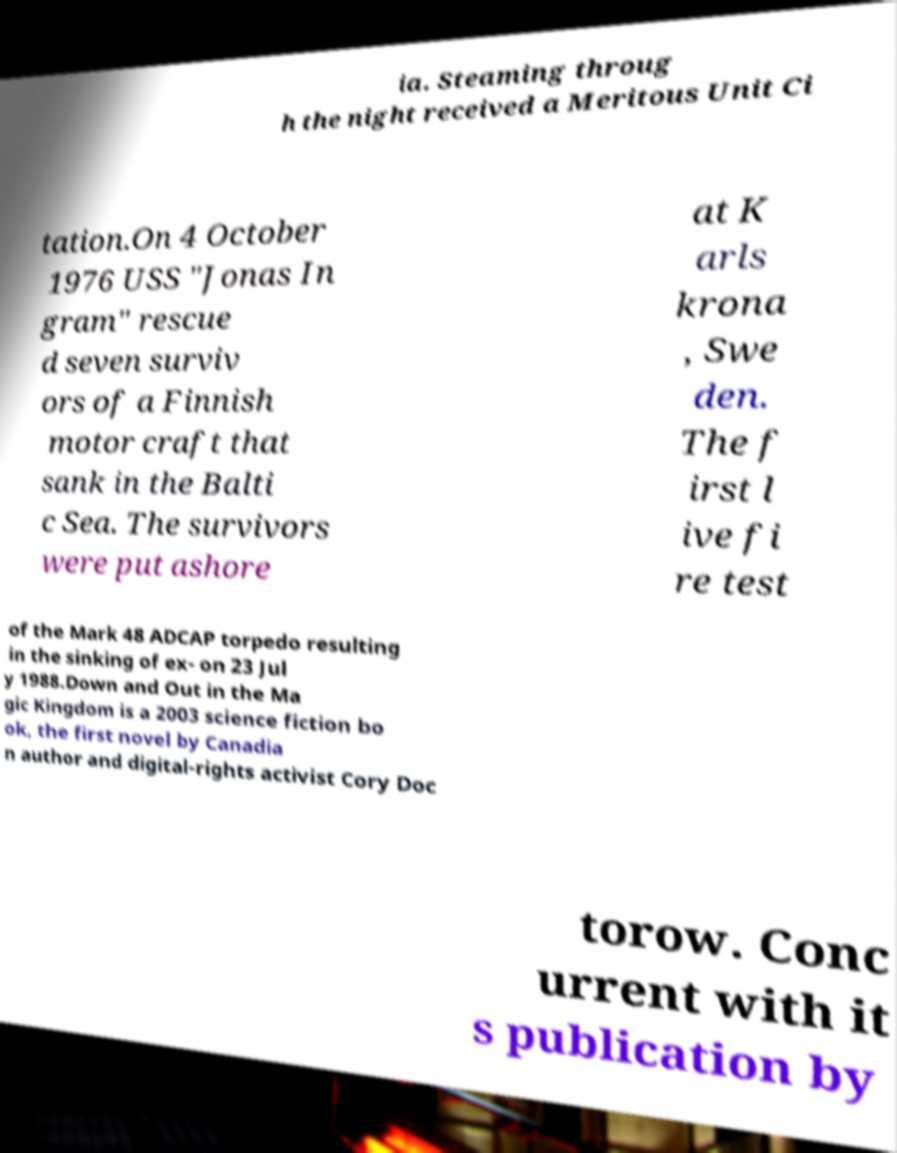For documentation purposes, I need the text within this image transcribed. Could you provide that? ia. Steaming throug h the night received a Meritous Unit Ci tation.On 4 October 1976 USS "Jonas In gram" rescue d seven surviv ors of a Finnish motor craft that sank in the Balti c Sea. The survivors were put ashore at K arls krona , Swe den. The f irst l ive fi re test of the Mark 48 ADCAP torpedo resulting in the sinking of ex- on 23 Jul y 1988.Down and Out in the Ma gic Kingdom is a 2003 science fiction bo ok, the first novel by Canadia n author and digital-rights activist Cory Doc torow. Conc urrent with it s publication by 